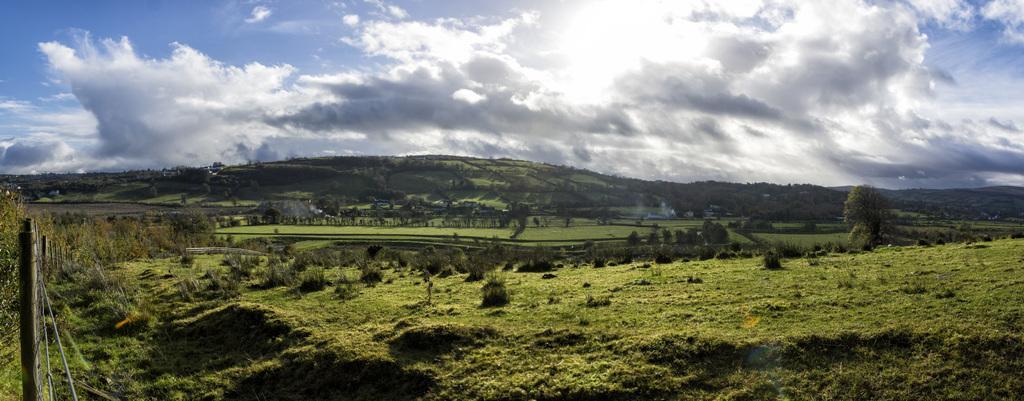Please provide a concise description of this image. In the picture I can see the natural scenery of green grass. I can see the metal fence on the bottom left side. In the background, I can see the farm fields, trees and hills. There are clouds in the sky. 